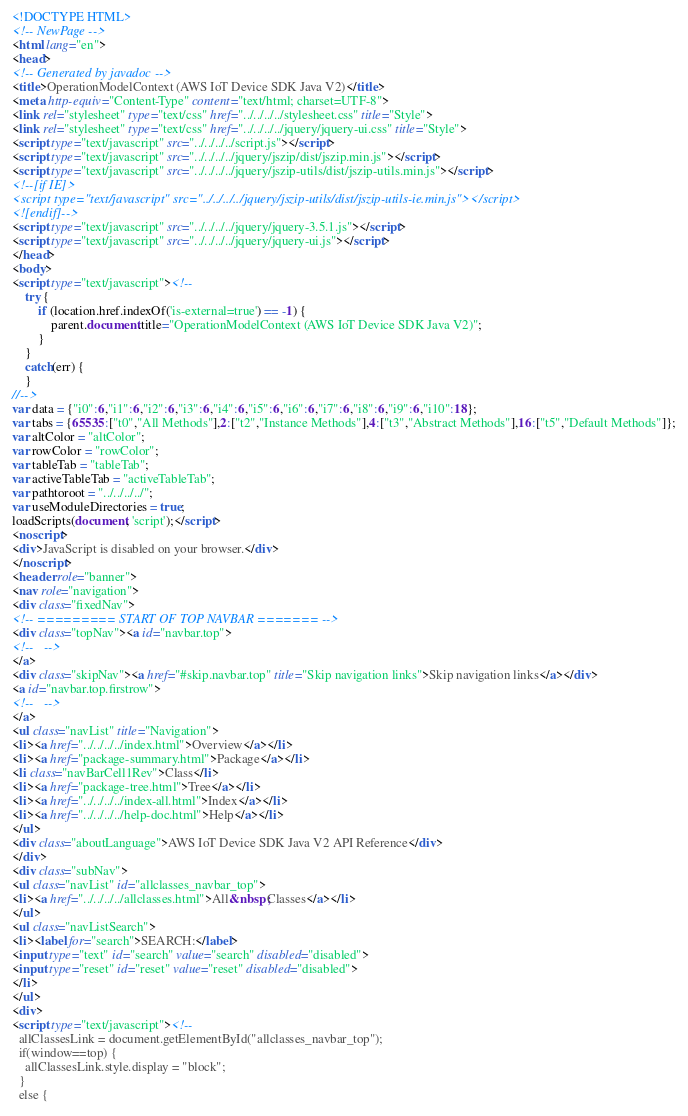Convert code to text. <code><loc_0><loc_0><loc_500><loc_500><_HTML_><!DOCTYPE HTML>
<!-- NewPage -->
<html lang="en">
<head>
<!-- Generated by javadoc -->
<title>OperationModelContext (AWS IoT Device SDK Java V2)</title>
<meta http-equiv="Content-Type" content="text/html; charset=UTF-8">
<link rel="stylesheet" type="text/css" href="../../../../stylesheet.css" title="Style">
<link rel="stylesheet" type="text/css" href="../../../../jquery/jquery-ui.css" title="Style">
<script type="text/javascript" src="../../../../script.js"></script>
<script type="text/javascript" src="../../../../jquery/jszip/dist/jszip.min.js"></script>
<script type="text/javascript" src="../../../../jquery/jszip-utils/dist/jszip-utils.min.js"></script>
<!--[if IE]>
<script type="text/javascript" src="../../../../jquery/jszip-utils/dist/jszip-utils-ie.min.js"></script>
<![endif]-->
<script type="text/javascript" src="../../../../jquery/jquery-3.5.1.js"></script>
<script type="text/javascript" src="../../../../jquery/jquery-ui.js"></script>
</head>
<body>
<script type="text/javascript"><!--
    try {
        if (location.href.indexOf('is-external=true') == -1) {
            parent.document.title="OperationModelContext (AWS IoT Device SDK Java V2)";
        }
    }
    catch(err) {
    }
//-->
var data = {"i0":6,"i1":6,"i2":6,"i3":6,"i4":6,"i5":6,"i6":6,"i7":6,"i8":6,"i9":6,"i10":18};
var tabs = {65535:["t0","All Methods"],2:["t2","Instance Methods"],4:["t3","Abstract Methods"],16:["t5","Default Methods"]};
var altColor = "altColor";
var rowColor = "rowColor";
var tableTab = "tableTab";
var activeTableTab = "activeTableTab";
var pathtoroot = "../../../../";
var useModuleDirectories = true;
loadScripts(document, 'script');</script>
<noscript>
<div>JavaScript is disabled on your browser.</div>
</noscript>
<header role="banner">
<nav role="navigation">
<div class="fixedNav">
<!-- ========= START OF TOP NAVBAR ======= -->
<div class="topNav"><a id="navbar.top">
<!--   -->
</a>
<div class="skipNav"><a href="#skip.navbar.top" title="Skip navigation links">Skip navigation links</a></div>
<a id="navbar.top.firstrow">
<!--   -->
</a>
<ul class="navList" title="Navigation">
<li><a href="../../../../index.html">Overview</a></li>
<li><a href="package-summary.html">Package</a></li>
<li class="navBarCell1Rev">Class</li>
<li><a href="package-tree.html">Tree</a></li>
<li><a href="../../../../index-all.html">Index</a></li>
<li><a href="../../../../help-doc.html">Help</a></li>
</ul>
<div class="aboutLanguage">AWS IoT Device SDK Java V2 API Reference</div>
</div>
<div class="subNav">
<ul class="navList" id="allclasses_navbar_top">
<li><a href="../../../../allclasses.html">All&nbsp;Classes</a></li>
</ul>
<ul class="navListSearch">
<li><label for="search">SEARCH:</label>
<input type="text" id="search" value="search" disabled="disabled">
<input type="reset" id="reset" value="reset" disabled="disabled">
</li>
</ul>
<div>
<script type="text/javascript"><!--
  allClassesLink = document.getElementById("allclasses_navbar_top");
  if(window==top) {
    allClassesLink.style.display = "block";
  }
  else {</code> 